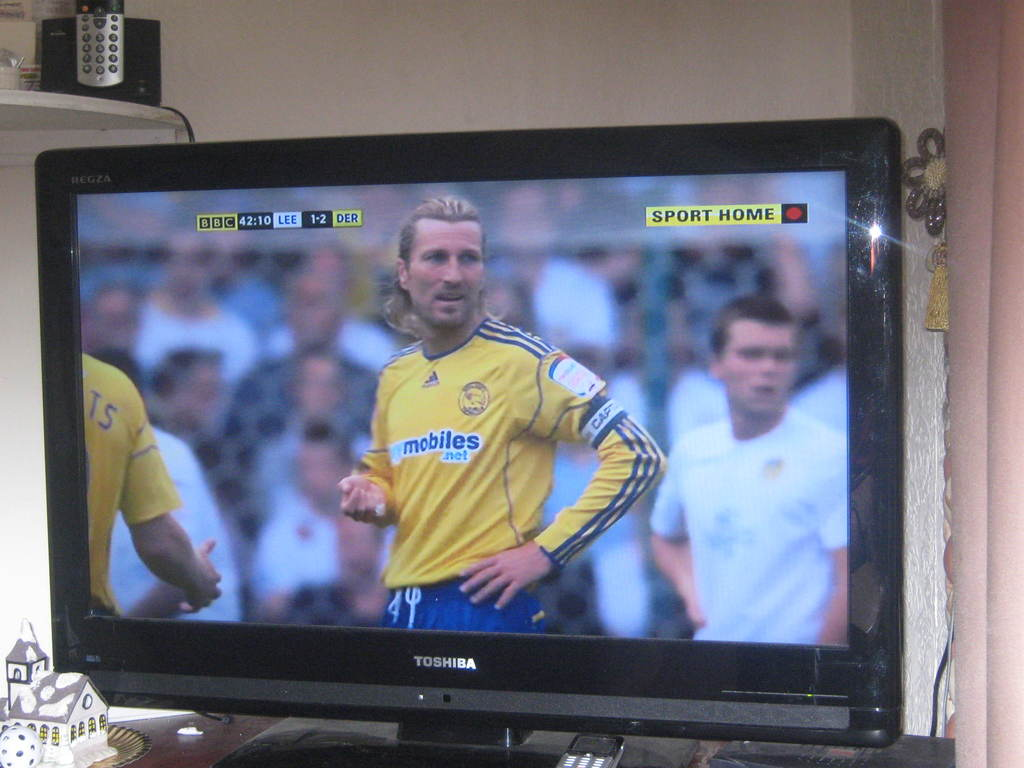Can you provide more details about the player in focus on the television? The player prominently displayed is wearing a yellow jersey and is likely a member of the Derby County team, identifiable by the match context and uniform. What is the significance of the '42:10' displayed on the TV? '42:10' represents the match time at the moment captured in the image, indicating it is nearing half-time of the soccer match. 